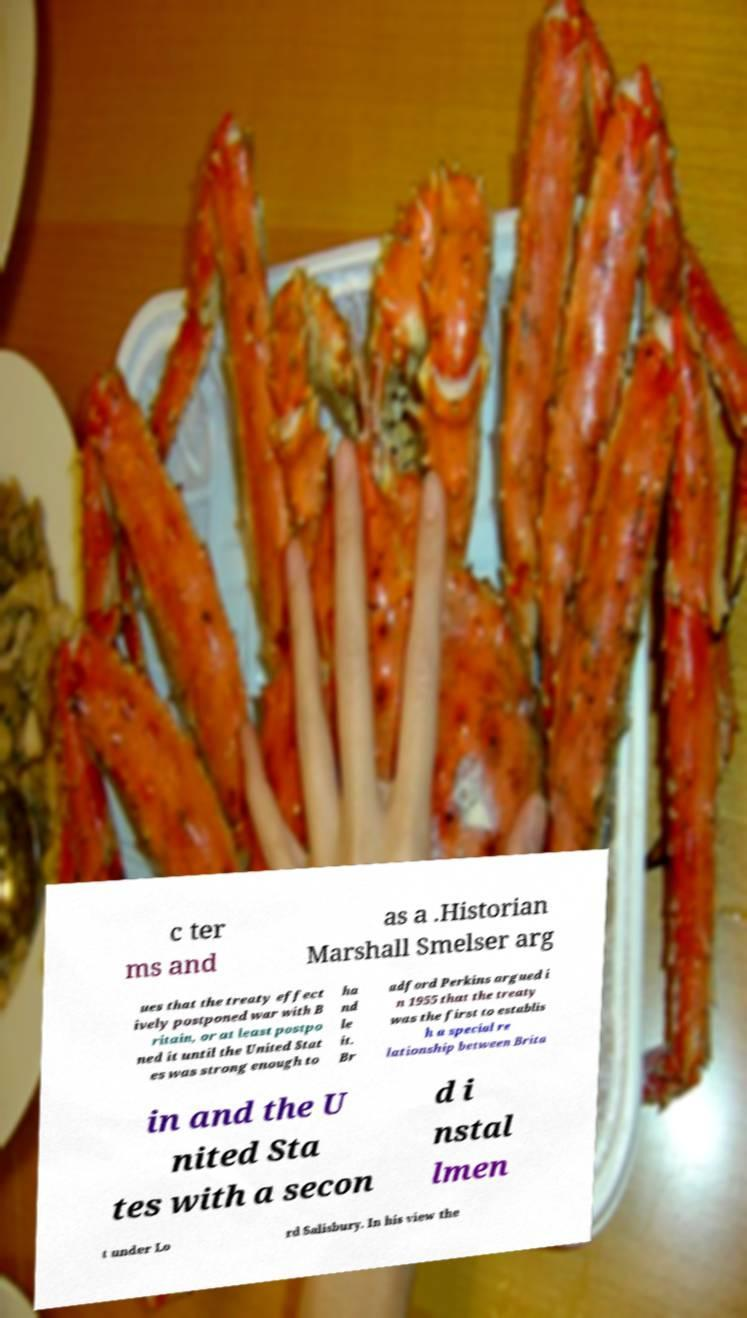Can you read and provide the text displayed in the image?This photo seems to have some interesting text. Can you extract and type it out for me? c ter ms and as a .Historian Marshall Smelser arg ues that the treaty effect ively postponed war with B ritain, or at least postpo ned it until the United Stat es was strong enough to ha nd le it. Br adford Perkins argued i n 1955 that the treaty was the first to establis h a special re lationship between Brita in and the U nited Sta tes with a secon d i nstal lmen t under Lo rd Salisbury. In his view the 